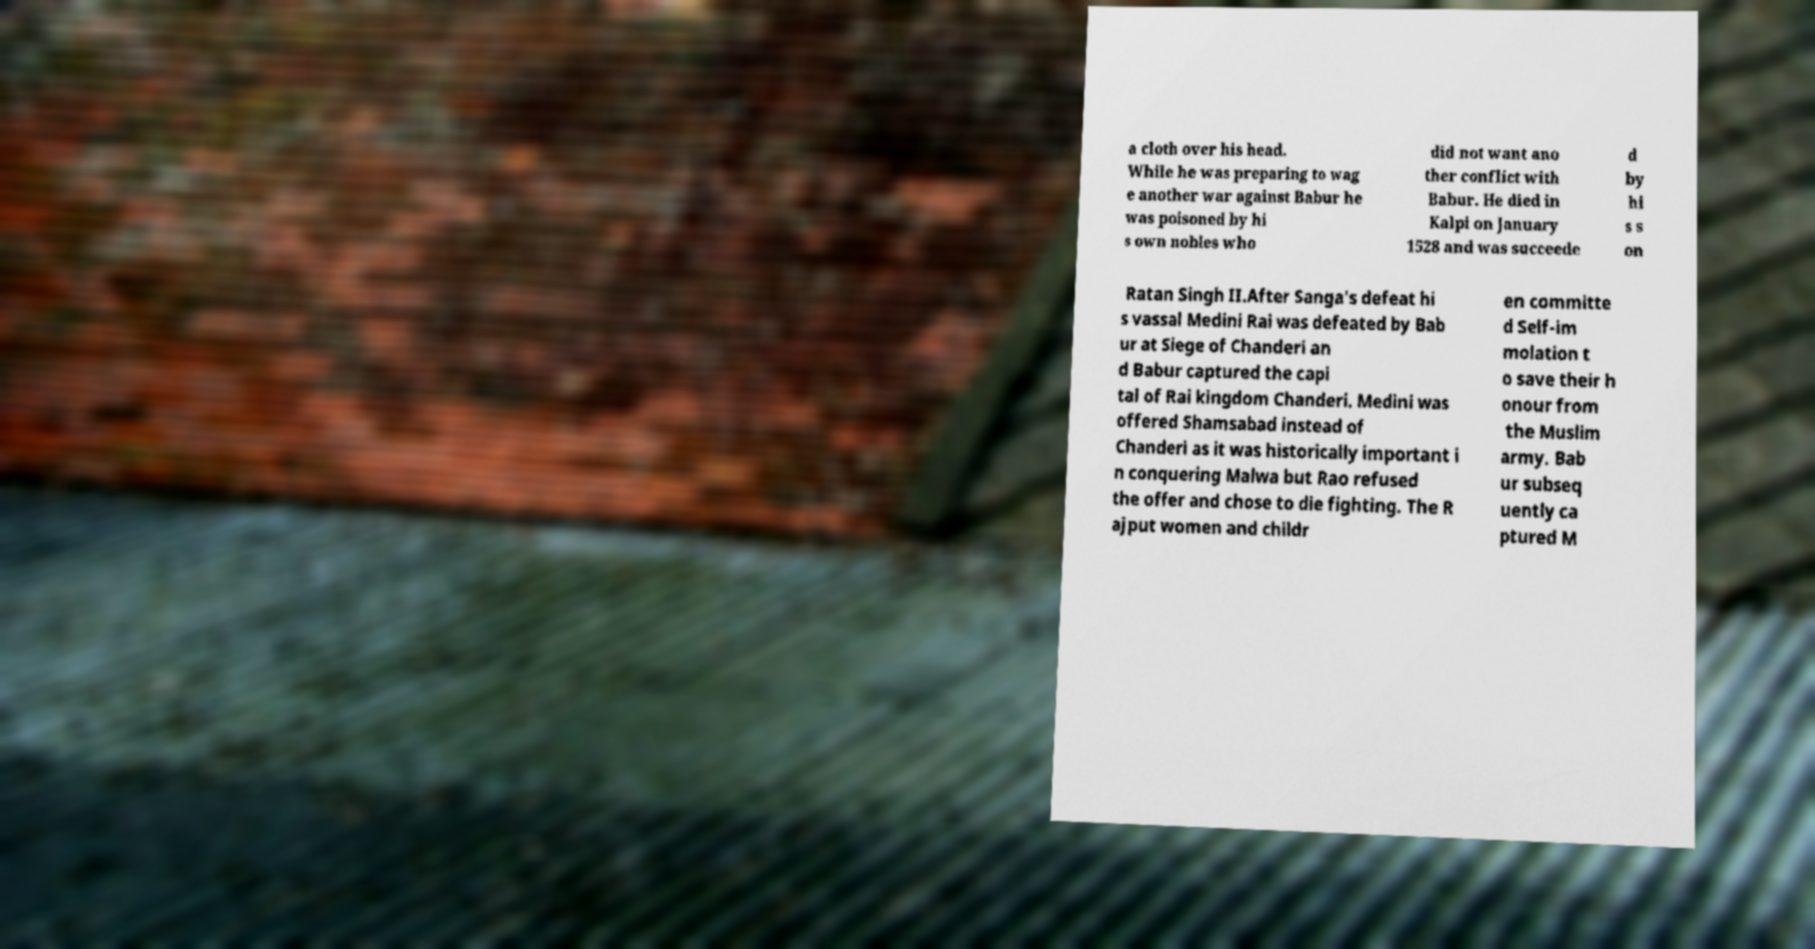Please identify and transcribe the text found in this image. a cloth over his head. While he was preparing to wag e another war against Babur he was poisoned by hi s own nobles who did not want ano ther conflict with Babur. He died in Kalpi on January 1528 and was succeede d by hi s s on Ratan Singh II.After Sanga's defeat hi s vassal Medini Rai was defeated by Bab ur at Siege of Chanderi an d Babur captured the capi tal of Rai kingdom Chanderi. Medini was offered Shamsabad instead of Chanderi as it was historically important i n conquering Malwa but Rao refused the offer and chose to die fighting. The R ajput women and childr en committe d Self-im molation t o save their h onour from the Muslim army. Bab ur subseq uently ca ptured M 